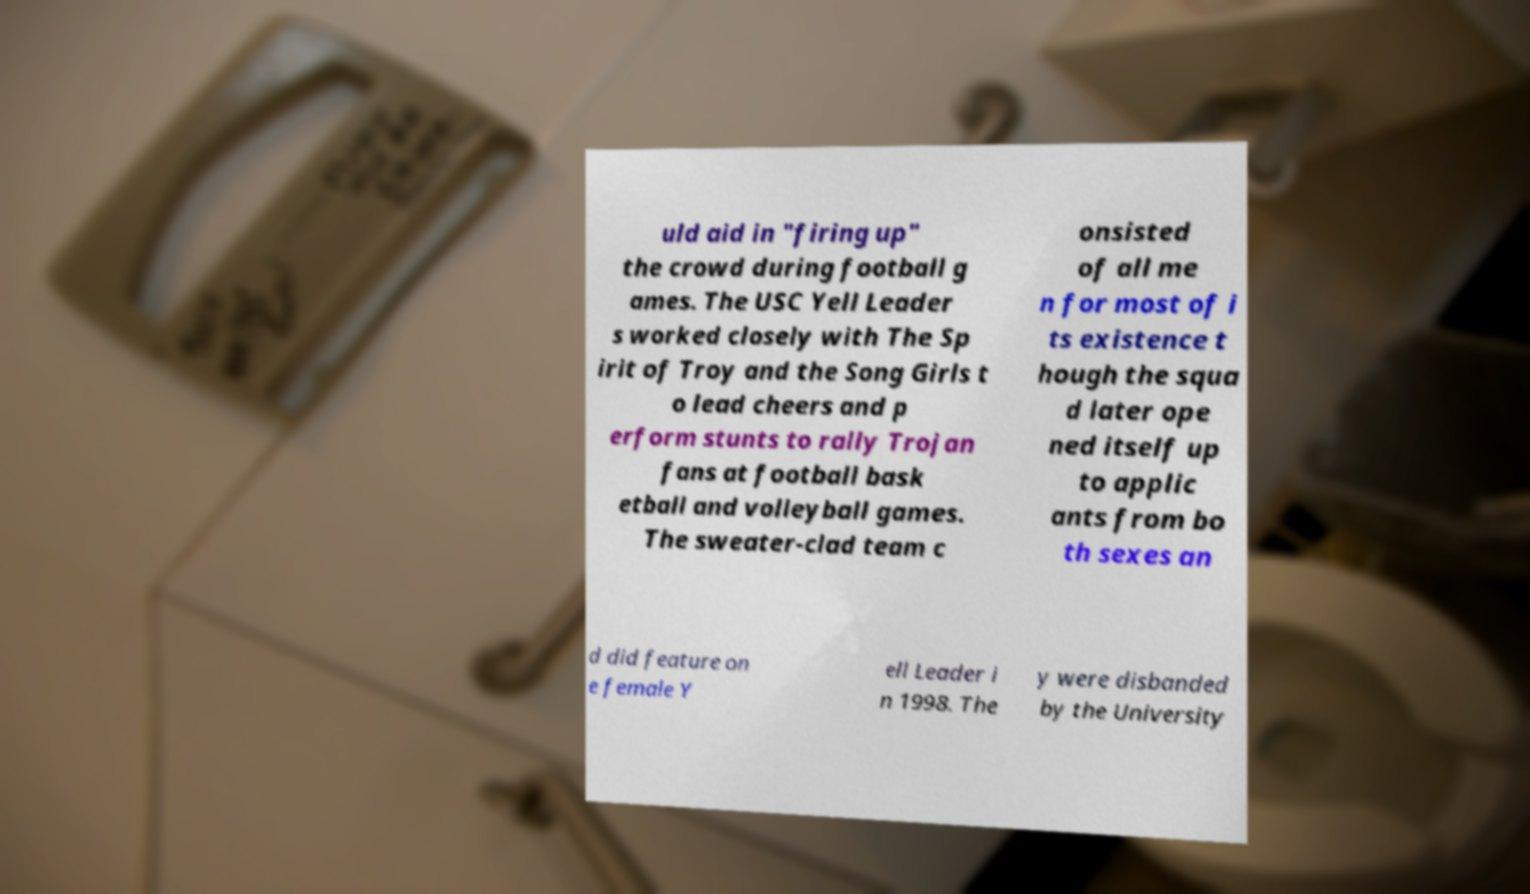Can you read and provide the text displayed in the image?This photo seems to have some interesting text. Can you extract and type it out for me? uld aid in "firing up" the crowd during football g ames. The USC Yell Leader s worked closely with The Sp irit of Troy and the Song Girls t o lead cheers and p erform stunts to rally Trojan fans at football bask etball and volleyball games. The sweater-clad team c onsisted of all me n for most of i ts existence t hough the squa d later ope ned itself up to applic ants from bo th sexes an d did feature on e female Y ell Leader i n 1998. The y were disbanded by the University 